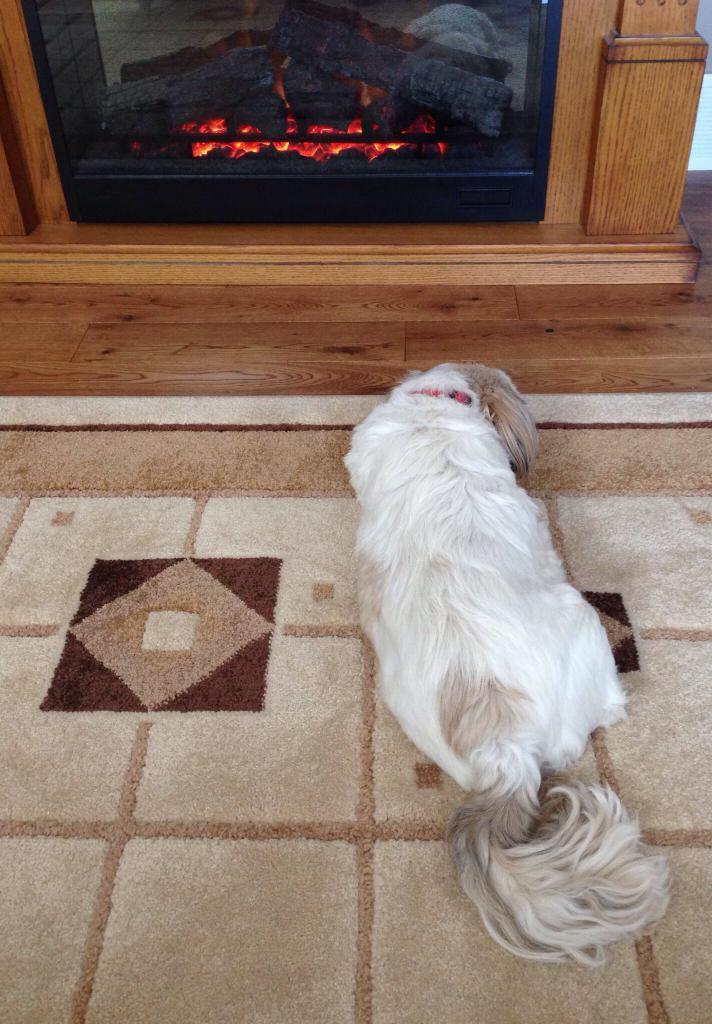Please provide a concise description of this image. In this image, we can see a white color dog on the carpet, there is a brown color floor. 